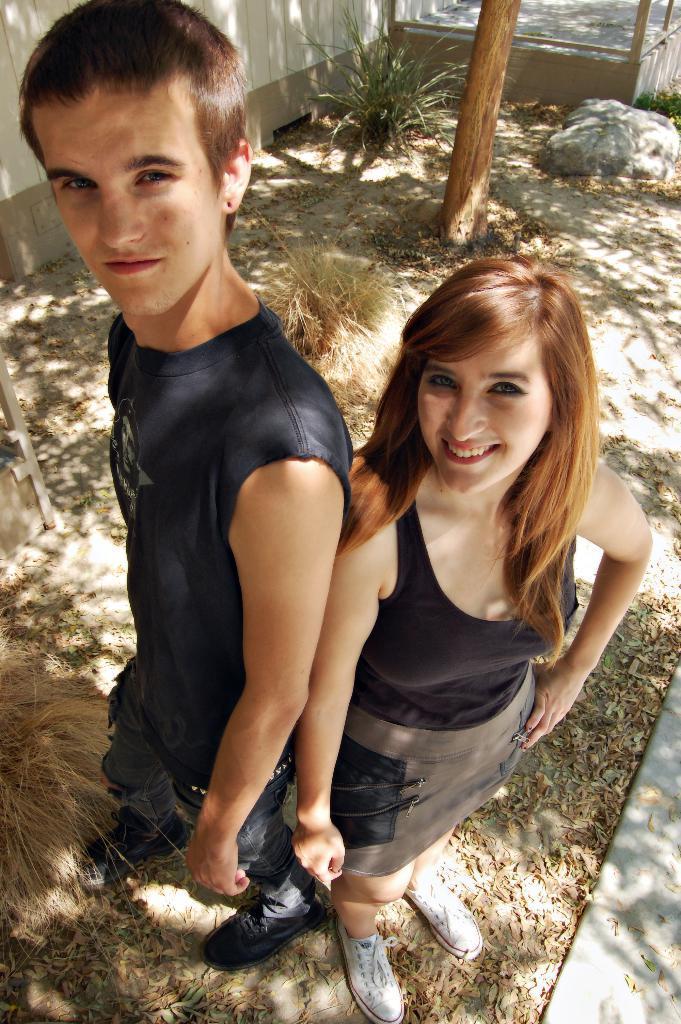Could you give a brief overview of what you see in this image? Here I can see a woman and a man standing on the ground, smiling and giving pose for the picture. In the background there are few plants and a stone on the ground and also there is a tree trunk. At the top of the image there is a wall. 